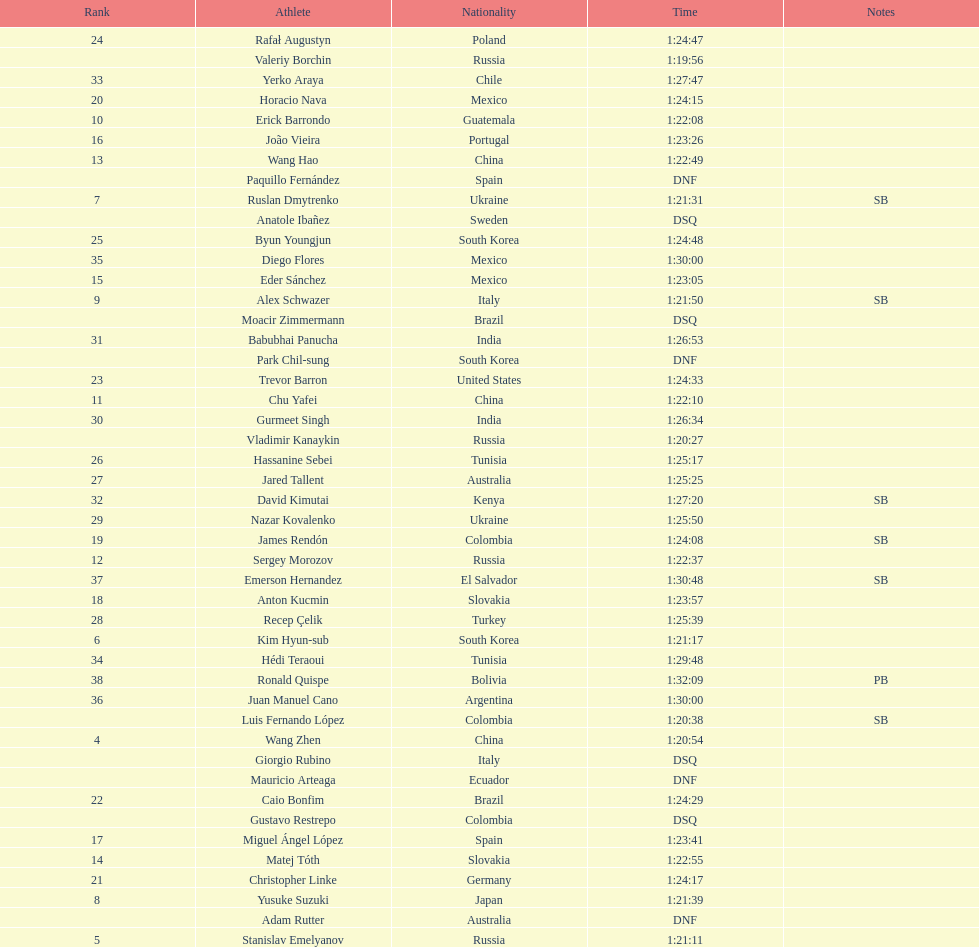What is the total count of athletes included in the rankings chart, including those classified as dsq & dnf? 46. 